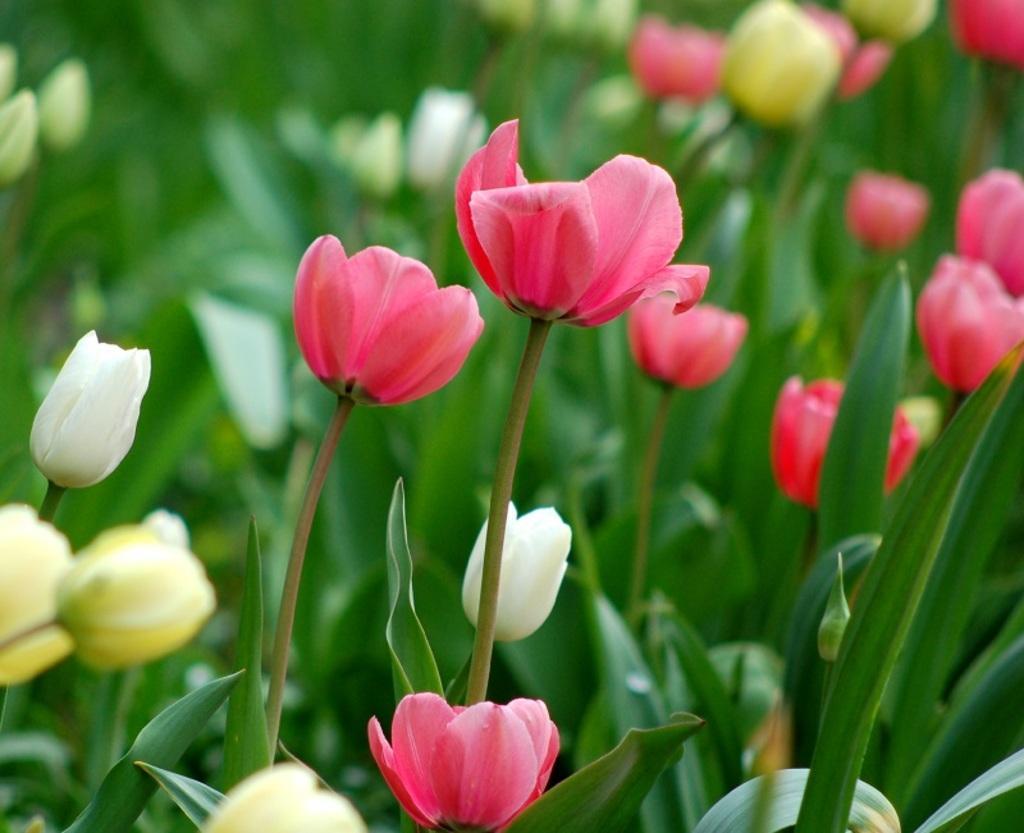Please provide a concise description of this image. In this picture there are pink, white and yellow color flowers on the plants. 